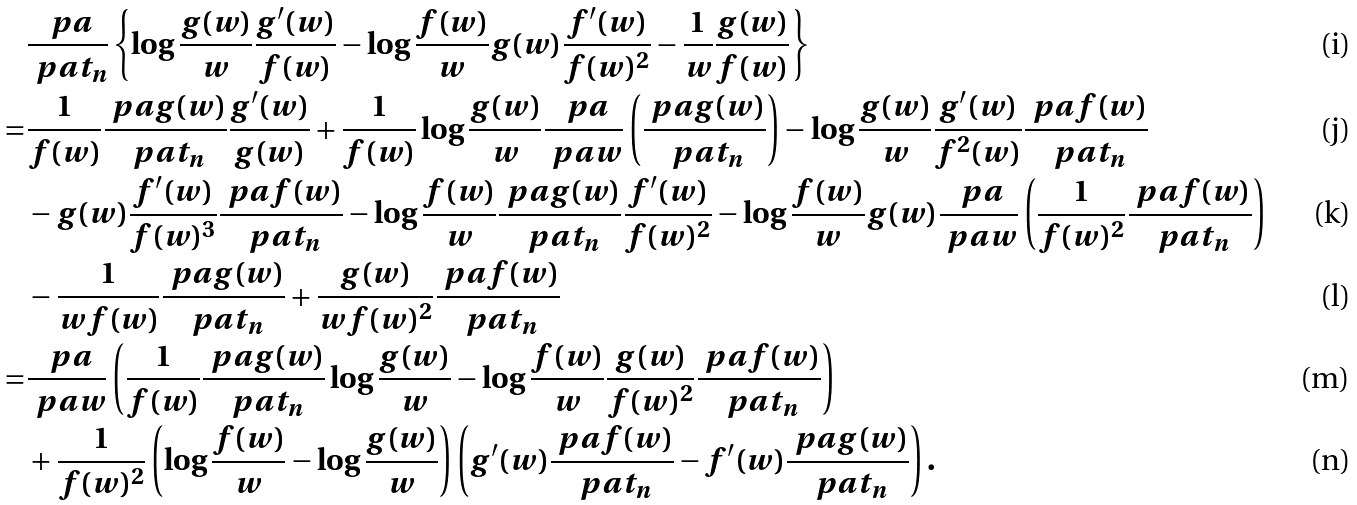<formula> <loc_0><loc_0><loc_500><loc_500>& \frac { \ p a } { \ p a t _ { n } } \left \{ \log \frac { g ( w ) } { w } \frac { g ^ { \prime } ( w ) } { f ( w ) } - \log \frac { f ( w ) } { w } g ( w ) \frac { f ^ { \prime } ( w ) } { f ( w ) ^ { 2 } } - \frac { 1 } { w } \frac { g ( w ) } { f ( w ) } \right \} \\ = & \frac { 1 } { f ( w ) } \frac { \ p a g ( w ) } { \ p a t _ { n } } \frac { g ^ { \prime } ( w ) } { g ( w ) } + \frac { 1 } { f ( w ) } \log \frac { g ( w ) } { w } \frac { \ p a } { \ p a w } \left ( \frac { \ p a g ( w ) } { \ p a t _ { n } } \right ) - \log \frac { g ( w ) } { w } \frac { g ^ { \prime } ( w ) } { f ^ { 2 } ( w ) } \frac { \ p a f ( w ) } { \ p a t _ { n } } \\ & - g ( w ) \frac { f ^ { \prime } ( w ) } { f ( w ) ^ { 3 } } \frac { \ p a f ( w ) } { \ p a t _ { n } } - \log \frac { f ( w ) } { w } \frac { \ p a g ( w ) } { \ p a t _ { n } } \frac { f ^ { \prime } ( w ) } { f ( w ) ^ { 2 } } - \log \frac { f ( w ) } { w } g ( w ) \frac { \ p a } { \ p a w } \left ( \frac { 1 } { f ( w ) ^ { 2 } } \frac { \ p a f ( w ) } { \ p a t _ { n } } \right ) \\ & - \frac { 1 } { w f ( w ) } \frac { \ p a g ( w ) } { \ p a t _ { n } } + \frac { g ( w ) } { w f ( w ) ^ { 2 } } \frac { \ p a f ( w ) } { \ p a t _ { n } } \\ = & \frac { \ p a } { \ p a w } \left ( \frac { 1 } { f ( w ) } \frac { \ p a g ( w ) } { \ p a t _ { n } } \log \frac { g ( w ) } { w } - \log \frac { f ( w ) } { w } \frac { g ( w ) } { f ( w ) ^ { 2 } } \frac { \ p a f ( w ) } { \ p a t _ { n } } \right ) \\ & + \frac { 1 } { f ( w ) ^ { 2 } } \left ( \log \frac { f ( w ) } { w } - \log \frac { g ( w ) } { w } \right ) \left ( g ^ { \prime } ( w ) \frac { \ p a f ( w ) } { \ p a t _ { n } } - f ^ { \prime } ( w ) \frac { \ p a g ( w ) } { \ p a t _ { n } } \right ) .</formula> 